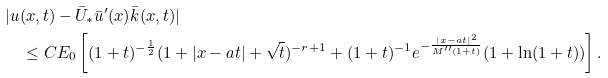Convert formula to latex. <formula><loc_0><loc_0><loc_500><loc_500>& | u ( x , t ) - \bar { U } _ { * } \bar { u } ^ { \prime } ( x ) \bar { k } ( x , t ) | \\ & \quad \leq C E _ { 0 } \left [ ( 1 + t ) ^ { - \frac { 1 } { 2 } } ( 1 + | x - a t | + \sqrt { t } ) ^ { - r + 1 } + ( 1 + t ) ^ { - 1 } e ^ { - \frac { | x - a t | ^ { 2 } } { M ^ { \prime \prime } ( 1 + t ) } } ( 1 + \ln ( 1 + t ) ) \right ] .</formula> 